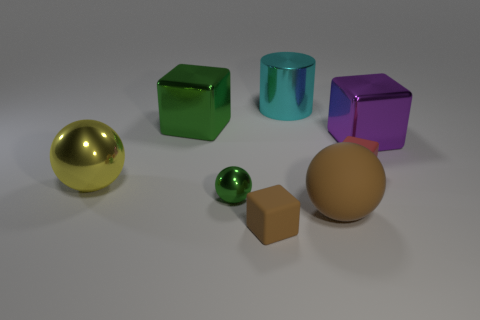Subtract all brown blocks. How many blocks are left? 3 Subtract all metallic balls. How many balls are left? 1 Subtract 1 balls. How many balls are left? 2 Add 1 big yellow shiny balls. How many objects exist? 9 Subtract all blue cubes. Subtract all brown cylinders. How many cubes are left? 4 Add 3 purple blocks. How many purple blocks are left? 4 Add 6 big yellow objects. How many big yellow objects exist? 7 Subtract 0 blue cylinders. How many objects are left? 8 Subtract all cylinders. How many objects are left? 7 Subtract all matte cubes. Subtract all metallic cylinders. How many objects are left? 5 